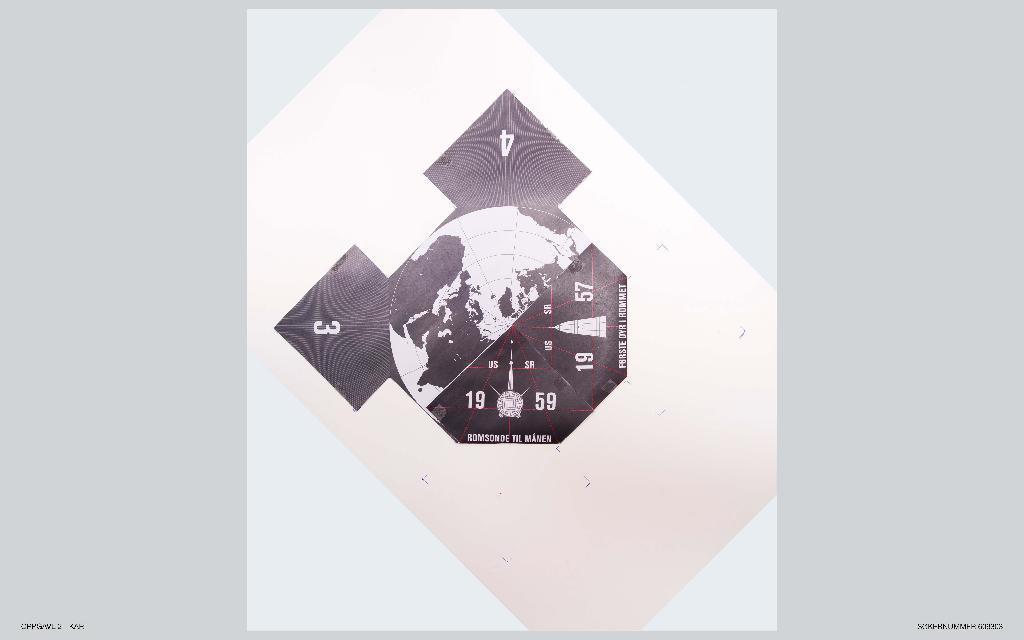Could you give a brief overview of what you see in this image? In this image we can see the picture of a globe with some numbers on it. 